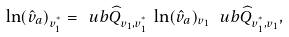Convert formula to latex. <formula><loc_0><loc_0><loc_500><loc_500>\ln ( { \hat { v } } _ { a } ) _ { v _ { 1 } ^ { ^ { * } } } = \ u b { \widehat { Q } } _ { v _ { 1 } , v _ { 1 } ^ { ^ { * } } } \, \ln ( \hat { v } _ { a } ) _ { v _ { 1 } } \, \ u b { \widehat { Q } } _ { v _ { 1 } ^ { ^ { * } } , v _ { 1 } } ,</formula> 